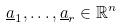Convert formula to latex. <formula><loc_0><loc_0><loc_500><loc_500>\underline { a } _ { 1 } , \dots , \underline { a } _ { r } \in \mathbb { R } ^ { n }</formula> 